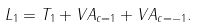<formula> <loc_0><loc_0><loc_500><loc_500>L _ { 1 } = T _ { 1 } + V A _ { c = 1 } + V A _ { c = - 1 } .</formula> 